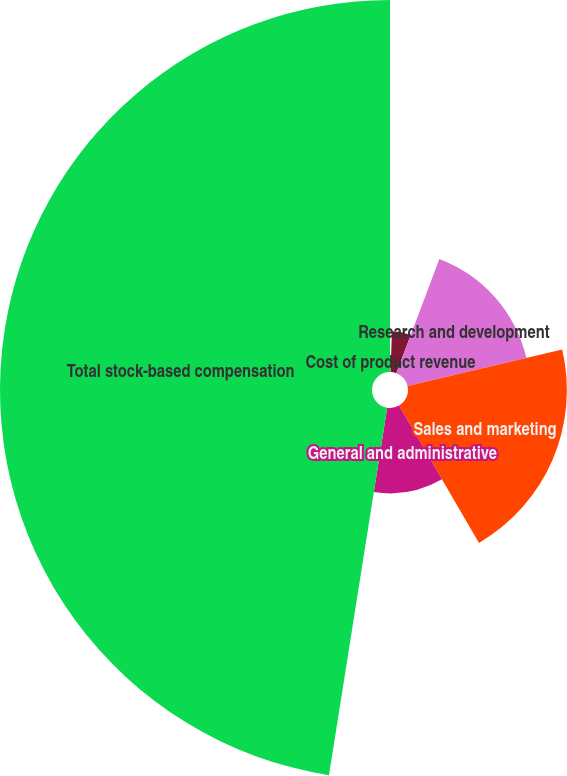<chart> <loc_0><loc_0><loc_500><loc_500><pie_chart><fcel>Cost of product revenue<fcel>Cost of services revenue<fcel>Research and development<fcel>Sales and marketing<fcel>General and administrative<fcel>Total stock-based compensation<nl><fcel>0.52%<fcel>5.21%<fcel>15.59%<fcel>20.29%<fcel>10.89%<fcel>47.5%<nl></chart> 